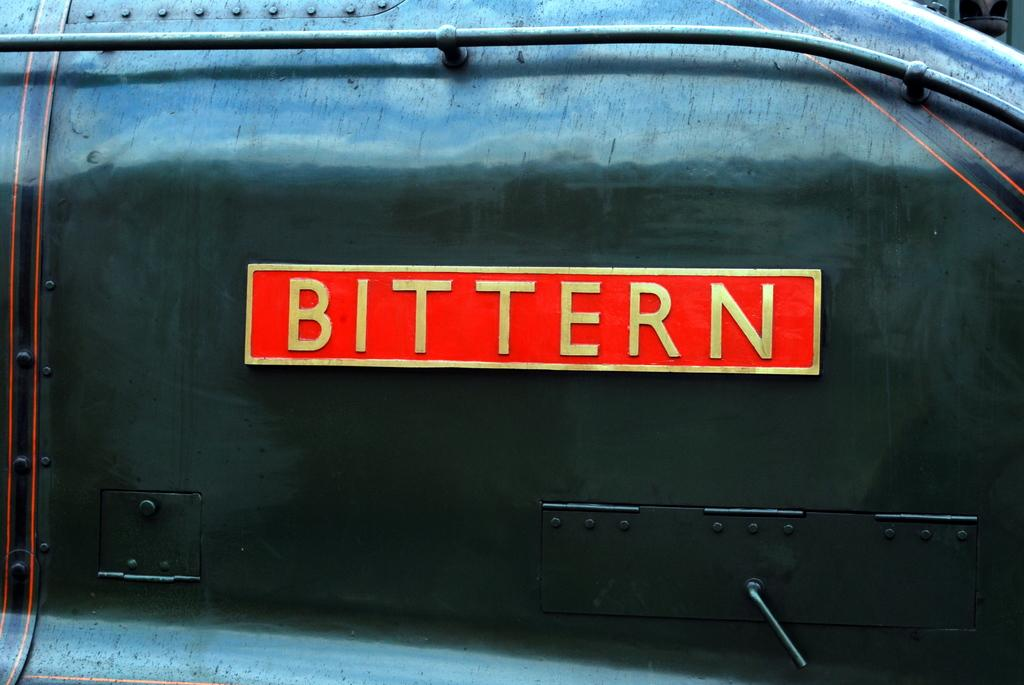<image>
Relay a brief, clear account of the picture shown. A photo of a machine that says Bittern. 